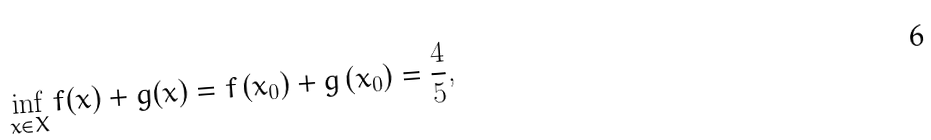Convert formula to latex. <formula><loc_0><loc_0><loc_500><loc_500>\inf _ { x \in X } f ( x ) + g ( x ) = f \left ( x _ { 0 } \right ) + g \left ( x _ { 0 } \right ) & = \frac { 4 } { 5 } ,</formula> 